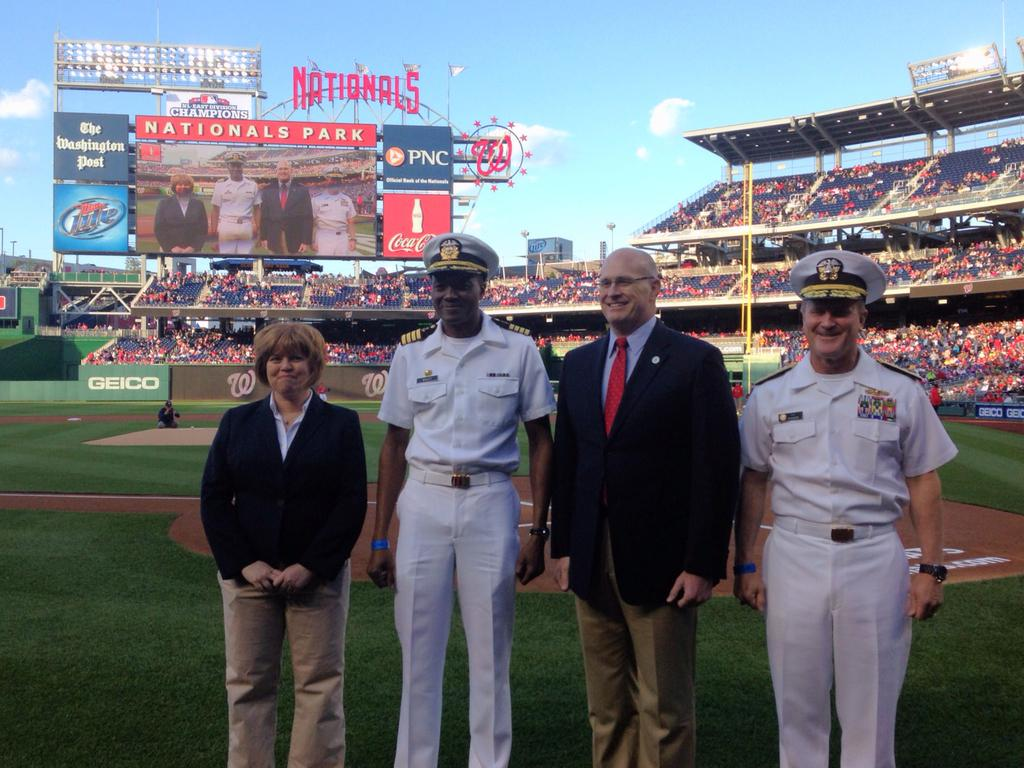<image>
Render a clear and concise summary of the photo. Four people stand on the field of Nationals Park. 